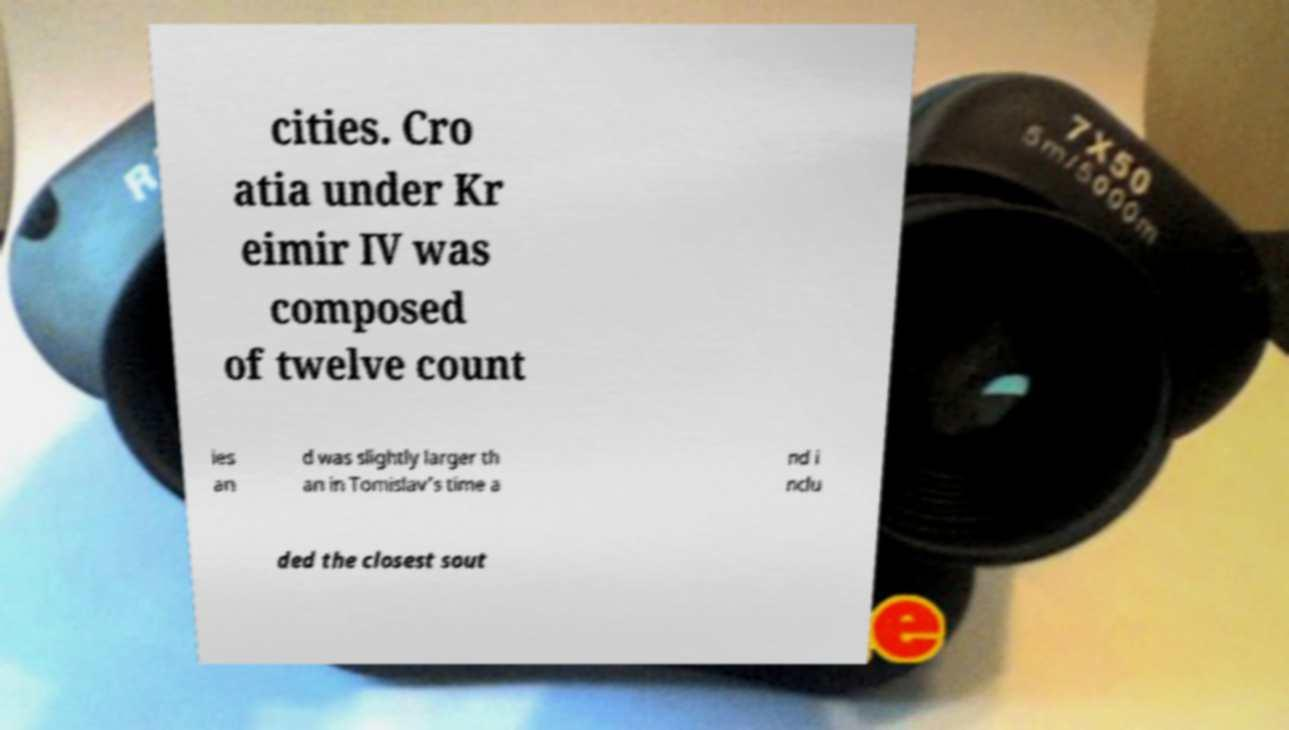Can you read and provide the text displayed in the image?This photo seems to have some interesting text. Can you extract and type it out for me? cities. Cro atia under Kr eimir IV was composed of twelve count ies an d was slightly larger th an in Tomislav's time a nd i nclu ded the closest sout 